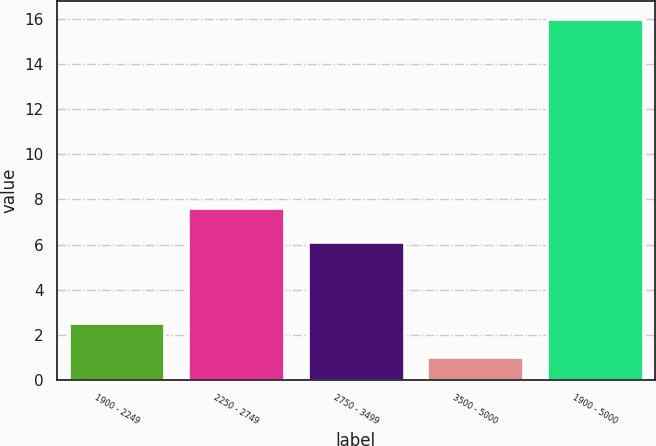Convert chart to OTSL. <chart><loc_0><loc_0><loc_500><loc_500><bar_chart><fcel>1900 - 2249<fcel>2250 - 2749<fcel>2750 - 3499<fcel>3500 - 5000<fcel>1900 - 5000<nl><fcel>2.5<fcel>7.6<fcel>6.1<fcel>1<fcel>16<nl></chart> 